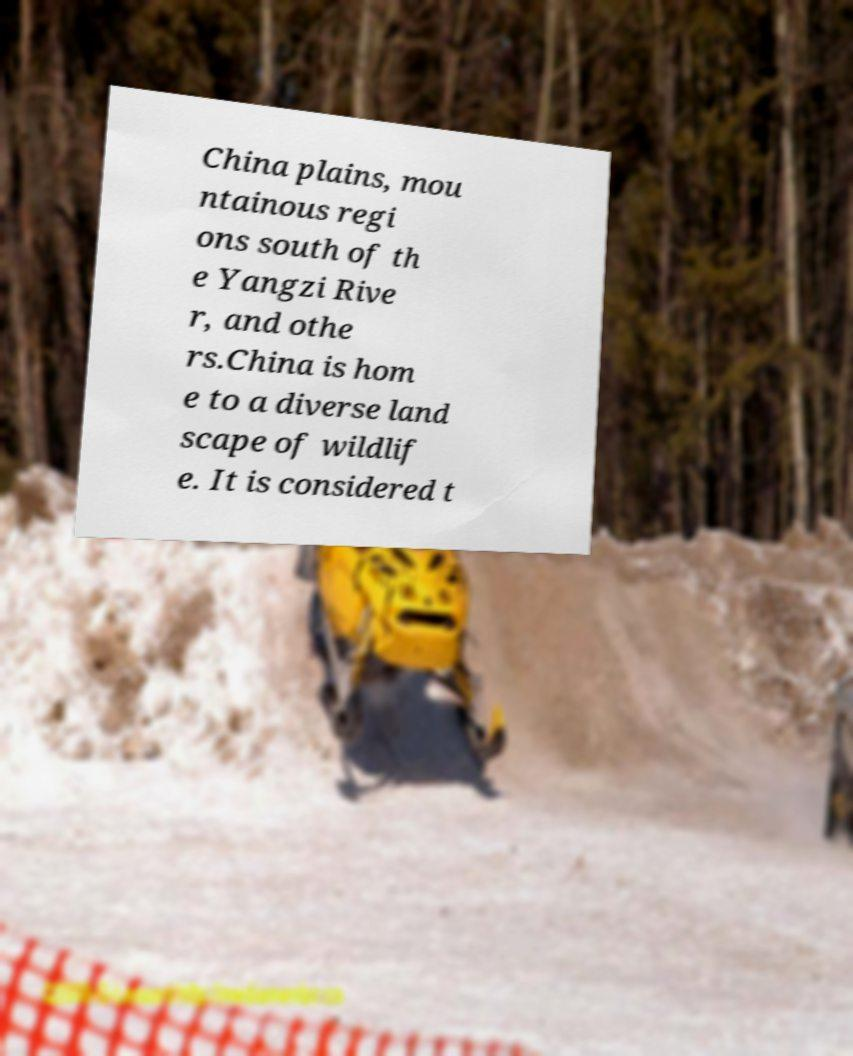There's text embedded in this image that I need extracted. Can you transcribe it verbatim? China plains, mou ntainous regi ons south of th e Yangzi Rive r, and othe rs.China is hom e to a diverse land scape of wildlif e. It is considered t 